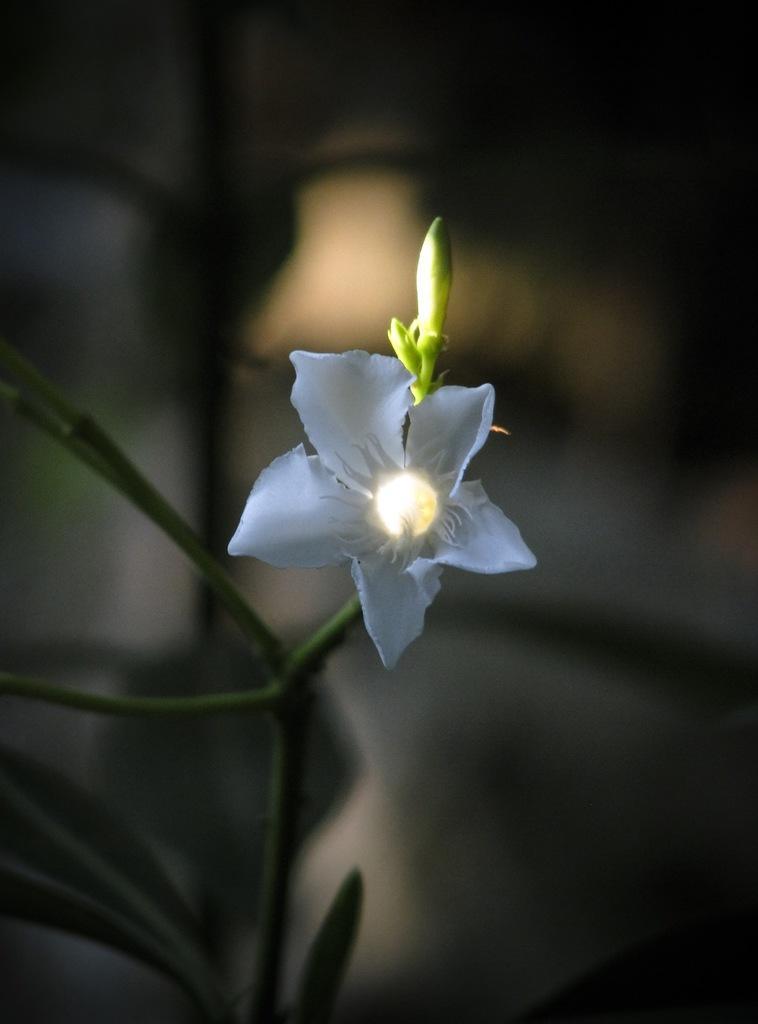How would you summarize this image in a sentence or two? In this image I can see the white color flower and the buds to the plant. I can see there is a blurred background. 